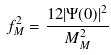<formula> <loc_0><loc_0><loc_500><loc_500>f _ { M } ^ { 2 } = \frac { 1 2 | \Psi ( 0 ) | ^ { 2 } } { M _ { M } ^ { 2 } }</formula> 